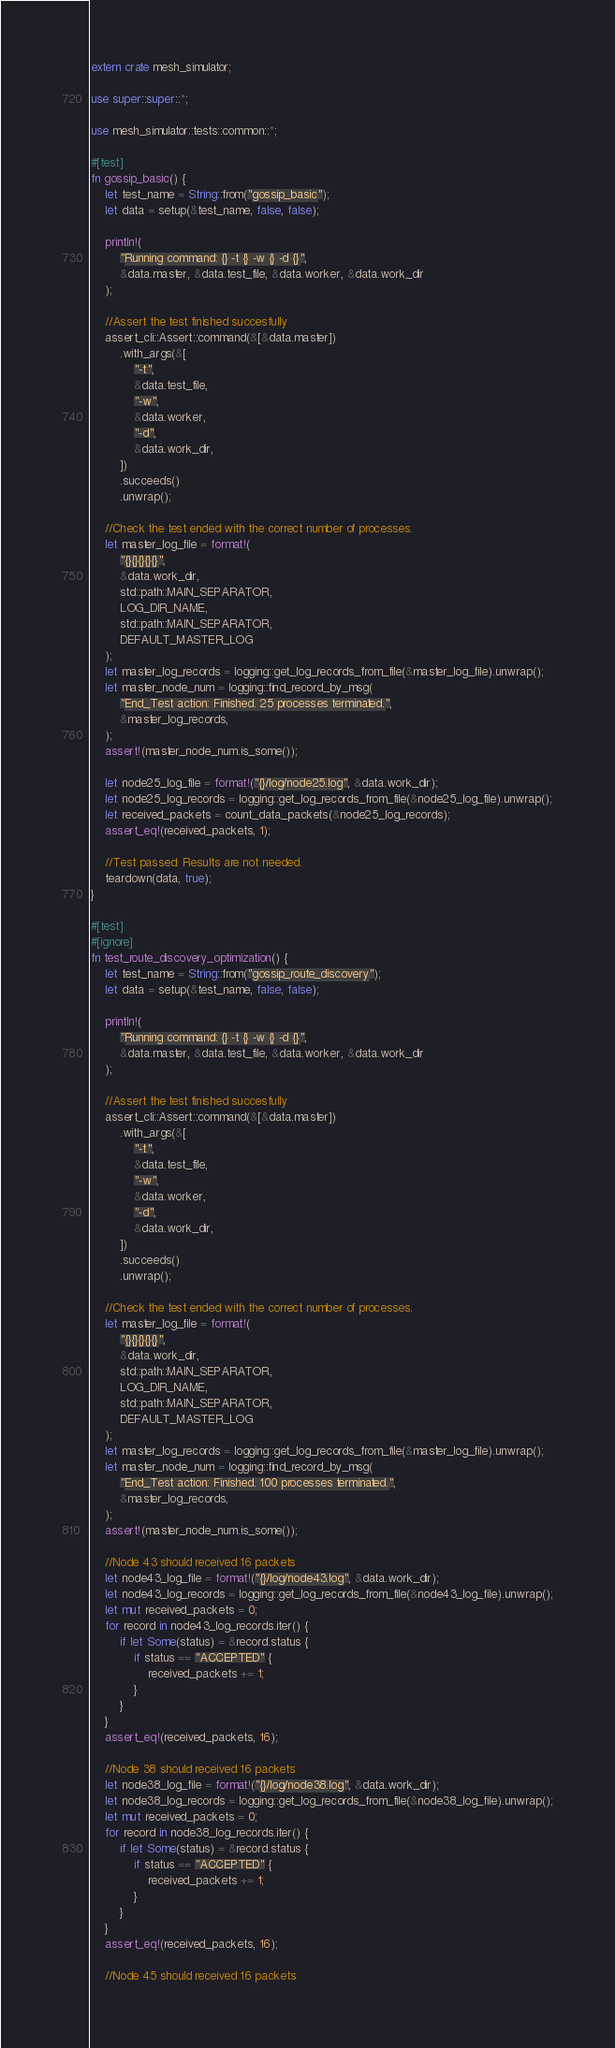Convert code to text. <code><loc_0><loc_0><loc_500><loc_500><_Rust_>extern crate mesh_simulator;

use super::super::*;

use mesh_simulator::tests::common::*;

#[test]
fn gossip_basic() {
    let test_name = String::from("gossip_basic");
    let data = setup(&test_name, false, false);

    println!(
        "Running command: {} -t {} -w {} -d {}",
        &data.master, &data.test_file, &data.worker, &data.work_dir
    );

    //Assert the test finished succesfully
    assert_cli::Assert::command(&[&data.master])
        .with_args(&[
            "-t",
            &data.test_file,
            "-w",
            &data.worker,
            "-d",
            &data.work_dir,
        ])
        .succeeds()
        .unwrap();

    //Check the test ended with the correct number of processes.
    let master_log_file = format!(
        "{}{}{}{}{}",
        &data.work_dir,
        std::path::MAIN_SEPARATOR,
        LOG_DIR_NAME,
        std::path::MAIN_SEPARATOR,
        DEFAULT_MASTER_LOG
    );
    let master_log_records = logging::get_log_records_from_file(&master_log_file).unwrap();
    let master_node_num = logging::find_record_by_msg(
        "End_Test action: Finished. 25 processes terminated.",
        &master_log_records,
    );
    assert!(master_node_num.is_some());

    let node25_log_file = format!("{}/log/node25.log", &data.work_dir);
    let node25_log_records = logging::get_log_records_from_file(&node25_log_file).unwrap();
    let received_packets = count_data_packets(&node25_log_records);
    assert_eq!(received_packets, 1);

    //Test passed. Results are not needed.
    teardown(data, true);
}

#[test]
#[ignore]
fn test_route_discovery_optimization() {
    let test_name = String::from("gossip_route_discovery");
    let data = setup(&test_name, false, false);

    println!(
        "Running command: {} -t {} -w {} -d {}",
        &data.master, &data.test_file, &data.worker, &data.work_dir
    );

    //Assert the test finished succesfully
    assert_cli::Assert::command(&[&data.master])
        .with_args(&[
            "-t",
            &data.test_file,
            "-w",
            &data.worker,
            "-d",
            &data.work_dir,
        ])
        .succeeds()
        .unwrap();

    //Check the test ended with the correct number of processes.
    let master_log_file = format!(
        "{}{}{}{}{}",
        &data.work_dir,
        std::path::MAIN_SEPARATOR,
        LOG_DIR_NAME,
        std::path::MAIN_SEPARATOR,
        DEFAULT_MASTER_LOG
    );
    let master_log_records = logging::get_log_records_from_file(&master_log_file).unwrap();
    let master_node_num = logging::find_record_by_msg(
        "End_Test action: Finished. 100 processes terminated.",
        &master_log_records,
    );
    assert!(master_node_num.is_some());

    //Node 43 should received 16 packets
    let node43_log_file = format!("{}/log/node43.log", &data.work_dir);
    let node43_log_records = logging::get_log_records_from_file(&node43_log_file).unwrap();
    let mut received_packets = 0;
    for record in node43_log_records.iter() {
        if let Some(status) = &record.status {
            if status == "ACCEPTED" {
                received_packets += 1;
            }
        }
    }
    assert_eq!(received_packets, 16);

    //Node 38 should received 16 packets
    let node38_log_file = format!("{}/log/node38.log", &data.work_dir);
    let node38_log_records = logging::get_log_records_from_file(&node38_log_file).unwrap();
    let mut received_packets = 0;
    for record in node38_log_records.iter() {
        if let Some(status) = &record.status {
            if status == "ACCEPTED" {
                received_packets += 1;
            }
        }
    }
    assert_eq!(received_packets, 16);

    //Node 45 should received 16 packets</code> 